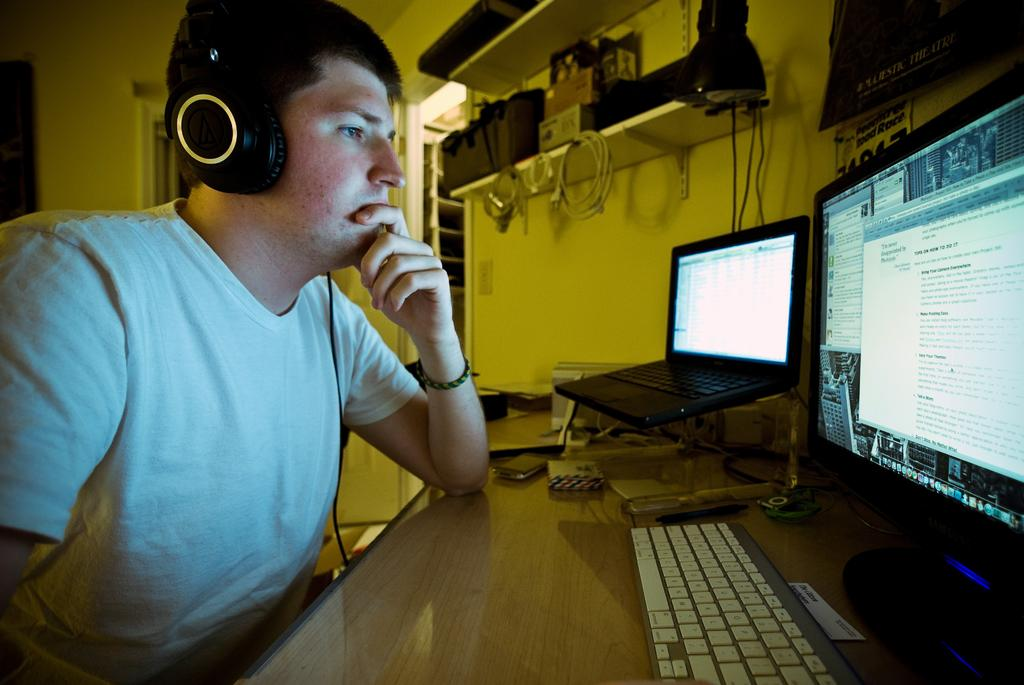What is the main subject of the image? The main subject of the image is a man. What is the man wearing in the image? The man is wearing clothes and headsets. What can be seen connected to the man in the image? There is a cable wire in the image. What is the man likely doing in the image? The man might be working, as there is a desk, keyboard, laptop, system, screen, and device present in the image. What type of furniture is in the image? There is a desk, shelf, and chair in the image. What type of lighting is present in the image? There is a light in the image. What type of access point is visible in the image? There is a door in the image. What type of jeans is the man wearing in the image? The provided facts do not mention the type of jeans the man is wearing, as the focus is on the clothes and headsets he is wearing. What type of milk is visible on the desk in the image? There is no milk present in the image; the focus is on the man, his clothing, and the work-related items on the desk. What type of protest is taking place outside the door in the image? There is no protest visible in the image; the focus is on the man, his clothing, and the work-related items on the desk. 